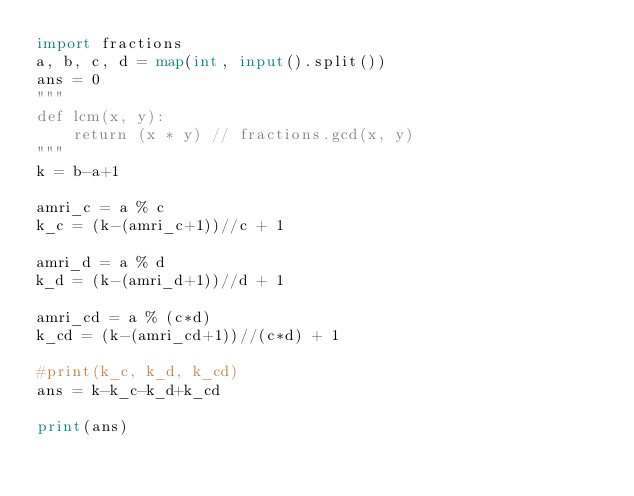Convert code to text. <code><loc_0><loc_0><loc_500><loc_500><_Python_>import fractions
a, b, c, d = map(int, input().split())
ans = 0
"""
def lcm(x, y):
    return (x * y) // fractions.gcd(x, y)
"""
k = b-a+1

amri_c = a % c
k_c = (k-(amri_c+1))//c + 1

amri_d = a % d
k_d = (k-(amri_d+1))//d + 1

amri_cd = a % (c*d)
k_cd = (k-(amri_cd+1))//(c*d) + 1

#print(k_c, k_d, k_cd)
ans = k-k_c-k_d+k_cd

print(ans)</code> 